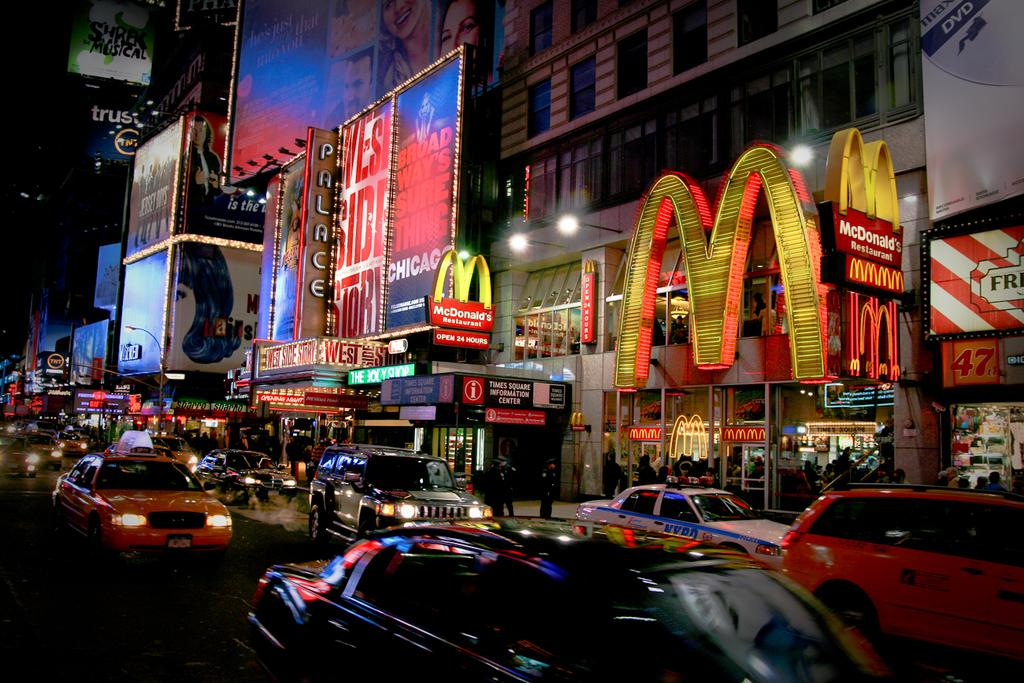<image>
Relay a brief, clear account of the picture shown. A street with lots of traffic in front of a building that says McDonald's. 